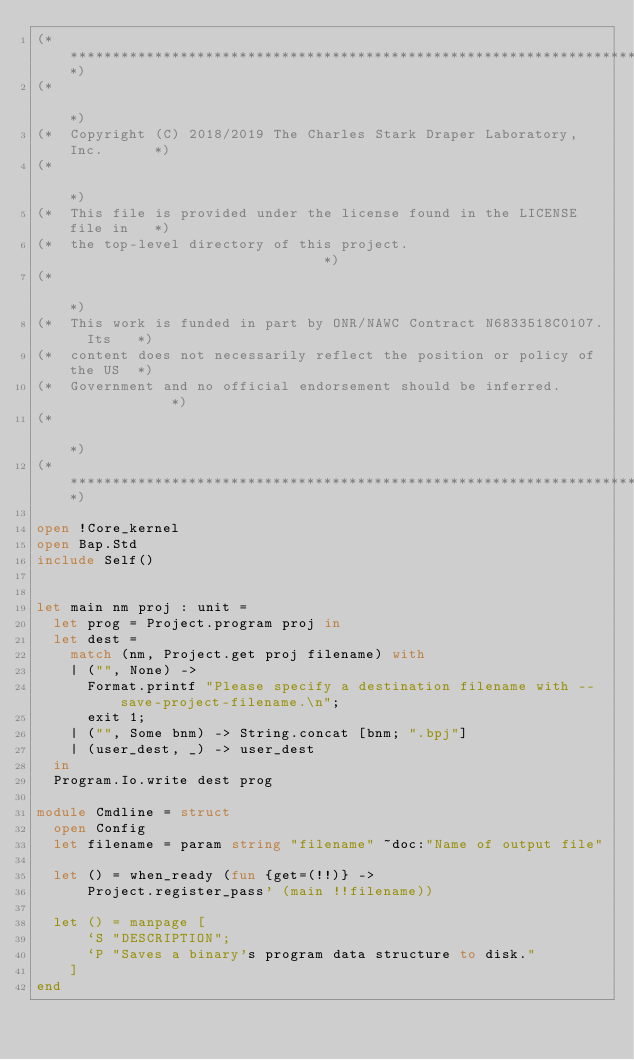Convert code to text. <code><loc_0><loc_0><loc_500><loc_500><_OCaml_>(***************************************************************************)
(*                                                                         *)
(*  Copyright (C) 2018/2019 The Charles Stark Draper Laboratory, Inc.      *)
(*                                                                         *)
(*  This file is provided under the license found in the LICENSE file in   *)
(*  the top-level directory of this project.                               *)
(*                                                                         *)
(*  This work is funded in part by ONR/NAWC Contract N6833518C0107.  Its   *)
(*  content does not necessarily reflect the position or policy of the US  *)
(*  Government and no official endorsement should be inferred.             *)
(*                                                                         *)
(***************************************************************************)

open !Core_kernel
open Bap.Std
include Self()


let main nm proj : unit =
  let prog = Project.program proj in
  let dest =
    match (nm, Project.get proj filename) with
    | ("", None) ->
      Format.printf "Please specify a destination filename with --save-project-filename.\n";
      exit 1;
    | ("", Some bnm) -> String.concat [bnm; ".bpj"]
    | (user_dest, _) -> user_dest
  in
  Program.Io.write dest prog

module Cmdline = struct
  open Config
  let filename = param string "filename" ~doc:"Name of output file"

  let () = when_ready (fun {get=(!!)} ->
      Project.register_pass' (main !!filename))

  let () = manpage [
      `S "DESCRIPTION";
      `P "Saves a binary's program data structure to disk."
    ]
end
</code> 